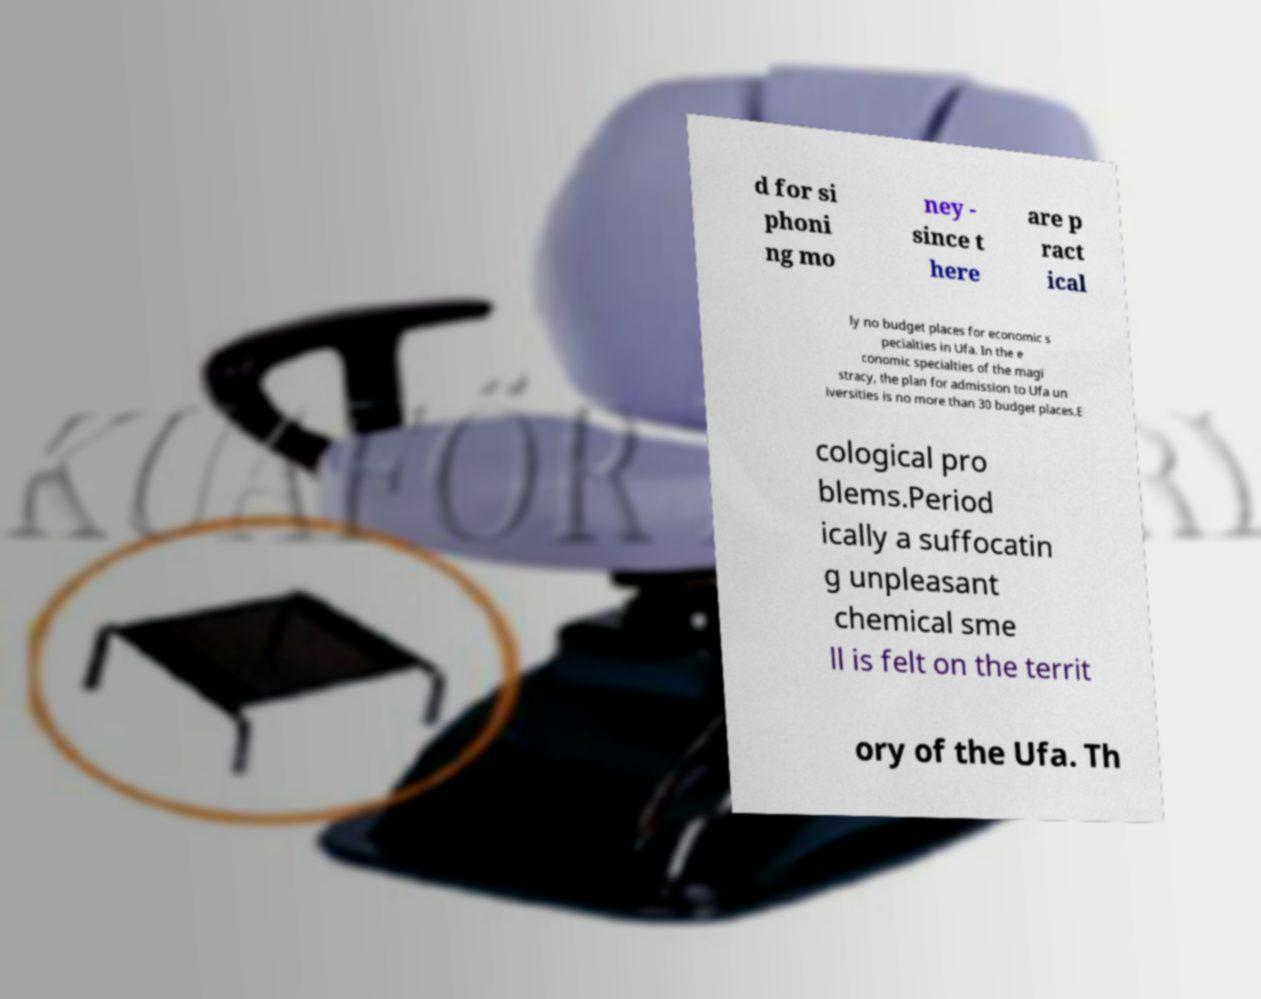Can you accurately transcribe the text from the provided image for me? d for si phoni ng mo ney - since t here are p ract ical ly no budget places for economic s pecialties in Ufa. In the e conomic specialties of the magi stracy, the plan for admission to Ufa un iversities is no more than 30 budget places.E cological pro blems.Period ically a suffocatin g unpleasant chemical sme ll is felt on the territ ory of the Ufa. Th 